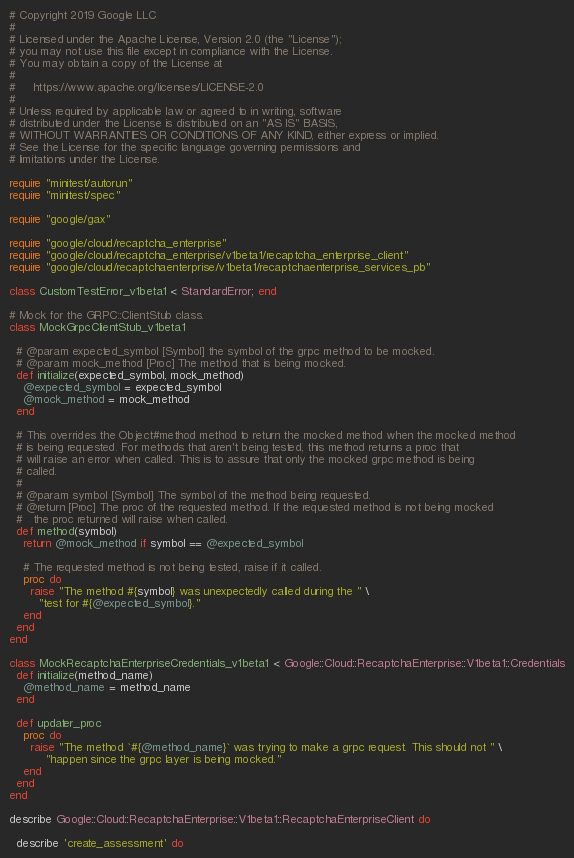<code> <loc_0><loc_0><loc_500><loc_500><_Ruby_># Copyright 2019 Google LLC
#
# Licensed under the Apache License, Version 2.0 (the "License");
# you may not use this file except in compliance with the License.
# You may obtain a copy of the License at
#
#     https://www.apache.org/licenses/LICENSE-2.0
#
# Unless required by applicable law or agreed to in writing, software
# distributed under the License is distributed on an "AS IS" BASIS,
# WITHOUT WARRANTIES OR CONDITIONS OF ANY KIND, either express or implied.
# See the License for the specific language governing permissions and
# limitations under the License.

require "minitest/autorun"
require "minitest/spec"

require "google/gax"

require "google/cloud/recaptcha_enterprise"
require "google/cloud/recaptcha_enterprise/v1beta1/recaptcha_enterprise_client"
require "google/cloud/recaptchaenterprise/v1beta1/recaptchaenterprise_services_pb"

class CustomTestError_v1beta1 < StandardError; end

# Mock for the GRPC::ClientStub class.
class MockGrpcClientStub_v1beta1

  # @param expected_symbol [Symbol] the symbol of the grpc method to be mocked.
  # @param mock_method [Proc] The method that is being mocked.
  def initialize(expected_symbol, mock_method)
    @expected_symbol = expected_symbol
    @mock_method = mock_method
  end

  # This overrides the Object#method method to return the mocked method when the mocked method
  # is being requested. For methods that aren't being tested, this method returns a proc that
  # will raise an error when called. This is to assure that only the mocked grpc method is being
  # called.
  #
  # @param symbol [Symbol] The symbol of the method being requested.
  # @return [Proc] The proc of the requested method. If the requested method is not being mocked
  #   the proc returned will raise when called.
  def method(symbol)
    return @mock_method if symbol == @expected_symbol

    # The requested method is not being tested, raise if it called.
    proc do
      raise "The method #{symbol} was unexpectedly called during the " \
        "test for #{@expected_symbol}."
    end
  end
end

class MockRecaptchaEnterpriseCredentials_v1beta1 < Google::Cloud::RecaptchaEnterprise::V1beta1::Credentials
  def initialize(method_name)
    @method_name = method_name
  end

  def updater_proc
    proc do
      raise "The method `#{@method_name}` was trying to make a grpc request. This should not " \
          "happen since the grpc layer is being mocked."
    end
  end
end

describe Google::Cloud::RecaptchaEnterprise::V1beta1::RecaptchaEnterpriseClient do

  describe 'create_assessment' do</code> 